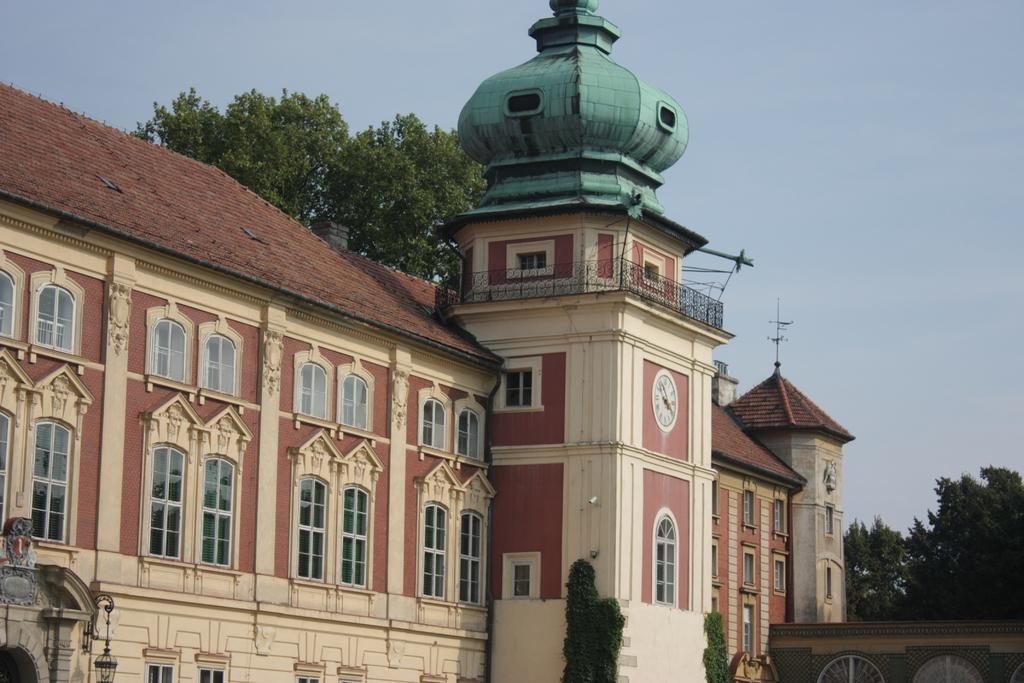Describe this image in one or two sentences. In this image we can see the building. Image also consists of trees. Sky is also visible. 